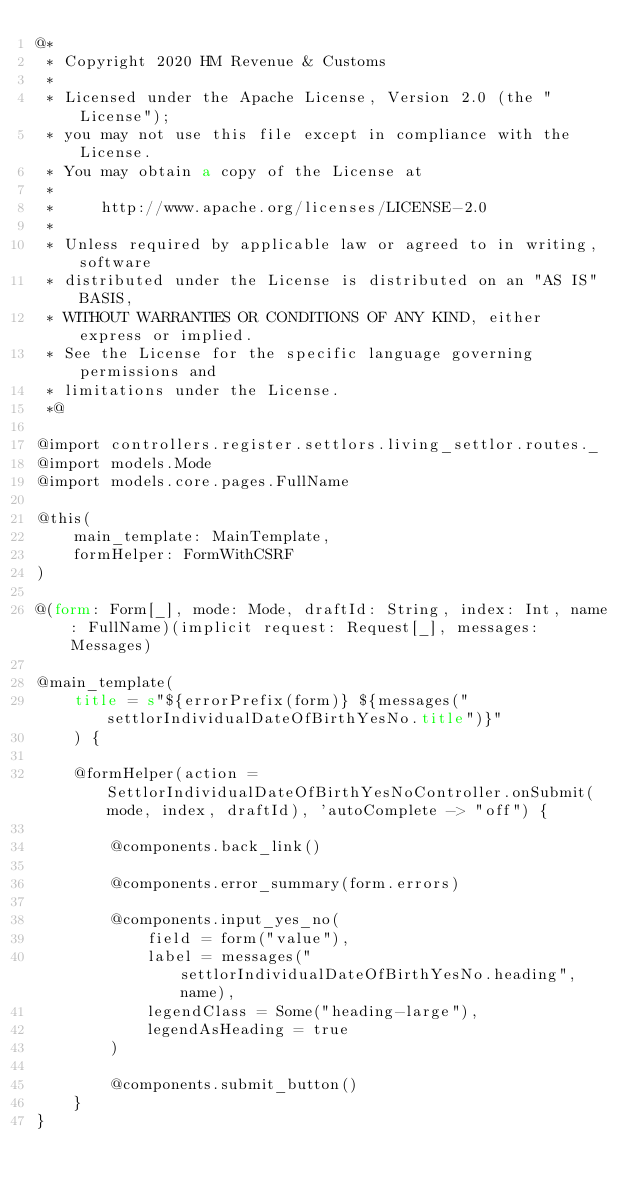Convert code to text. <code><loc_0><loc_0><loc_500><loc_500><_HTML_>@*
 * Copyright 2020 HM Revenue & Customs
 *
 * Licensed under the Apache License, Version 2.0 (the "License");
 * you may not use this file except in compliance with the License.
 * You may obtain a copy of the License at
 *
 *     http://www.apache.org/licenses/LICENSE-2.0
 *
 * Unless required by applicable law or agreed to in writing, software
 * distributed under the License is distributed on an "AS IS" BASIS,
 * WITHOUT WARRANTIES OR CONDITIONS OF ANY KIND, either express or implied.
 * See the License for the specific language governing permissions and
 * limitations under the License.
 *@

@import controllers.register.settlors.living_settlor.routes._
@import models.Mode
@import models.core.pages.FullName

@this(
    main_template: MainTemplate,
    formHelper: FormWithCSRF
)

@(form: Form[_], mode: Mode, draftId: String, index: Int, name: FullName)(implicit request: Request[_], messages: Messages)

@main_template(
    title = s"${errorPrefix(form)} ${messages("settlorIndividualDateOfBirthYesNo.title")}"
    ) {

    @formHelper(action = SettlorIndividualDateOfBirthYesNoController.onSubmit(mode, index, draftId), 'autoComplete -> "off") {

        @components.back_link()

        @components.error_summary(form.errors)

        @components.input_yes_no(
            field = form("value"),
            label = messages("settlorIndividualDateOfBirthYesNo.heading", name),
            legendClass = Some("heading-large"),
            legendAsHeading = true
        )

        @components.submit_button()
    }
}
</code> 